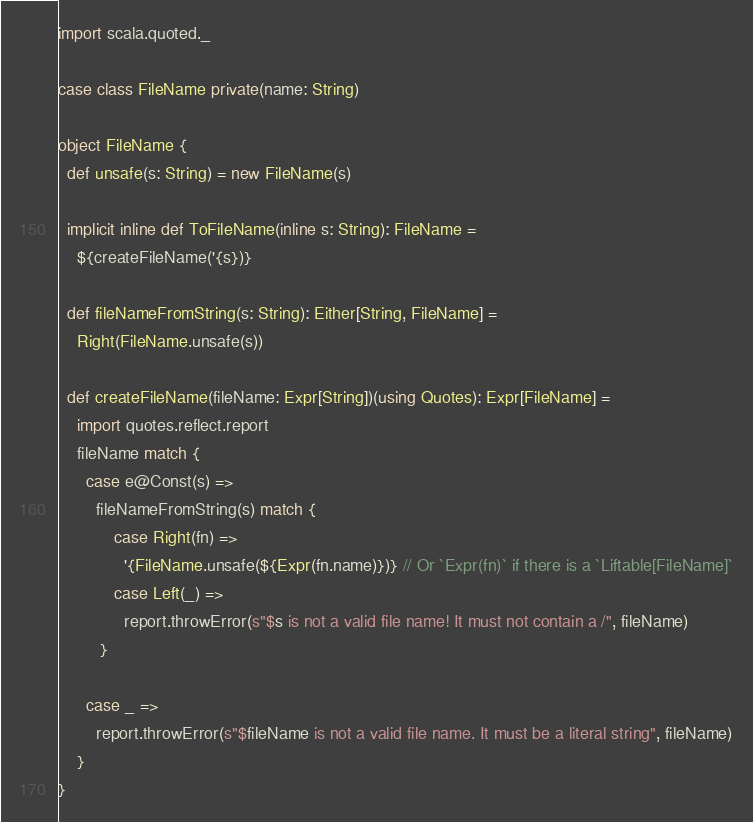Convert code to text. <code><loc_0><loc_0><loc_500><loc_500><_Scala_>import scala.quoted._

case class FileName private(name: String)

object FileName {
  def unsafe(s: String) = new FileName(s)

  implicit inline def ToFileName(inline s: String): FileName =
    ${createFileName('{s})}

  def fileNameFromString(s: String): Either[String, FileName] =
    Right(FileName.unsafe(s))

  def createFileName(fileName: Expr[String])(using Quotes): Expr[FileName] =
    import quotes.reflect.report
    fileName match {
      case e@Const(s) =>
        fileNameFromString(s) match {
            case Right(fn) =>
              '{FileName.unsafe(${Expr(fn.name)})} // Or `Expr(fn)` if there is a `Liftable[FileName]`
            case Left(_) =>
              report.throwError(s"$s is not a valid file name! It must not contain a /", fileName)
         }

      case _ =>
        report.throwError(s"$fileName is not a valid file name. It must be a literal string", fileName)
    }
}
</code> 